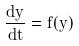Convert formula to latex. <formula><loc_0><loc_0><loc_500><loc_500>\frac { d y } { d t } = f ( y )</formula> 